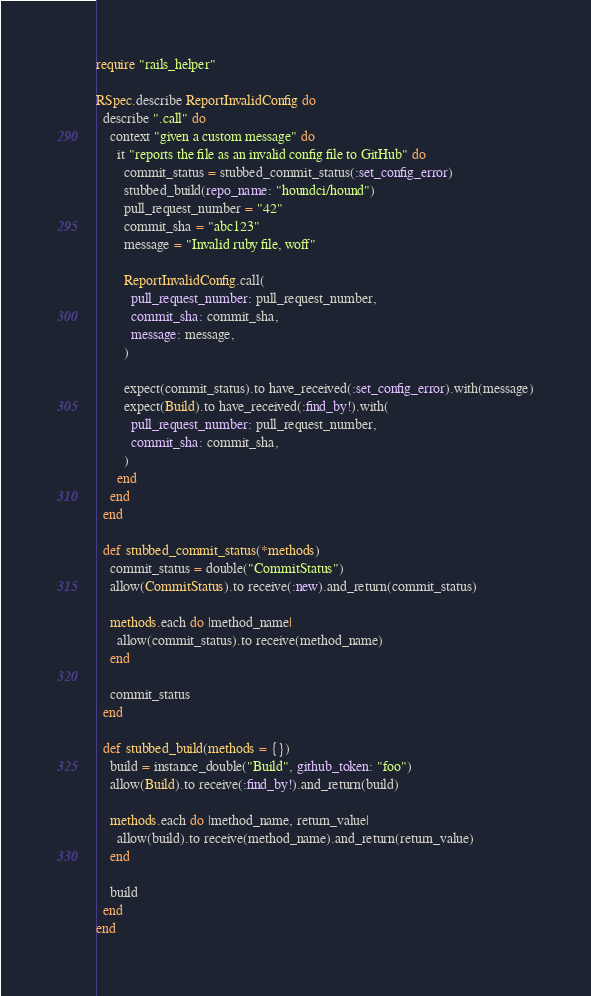Convert code to text. <code><loc_0><loc_0><loc_500><loc_500><_Ruby_>require "rails_helper"

RSpec.describe ReportInvalidConfig do
  describe ".call" do
    context "given a custom message" do
      it "reports the file as an invalid config file to GitHub" do
        commit_status = stubbed_commit_status(:set_config_error)
        stubbed_build(repo_name: "houndci/hound")
        pull_request_number = "42"
        commit_sha = "abc123"
        message = "Invalid ruby file, woff"

        ReportInvalidConfig.call(
          pull_request_number: pull_request_number,
          commit_sha: commit_sha,
          message: message,
        )

        expect(commit_status).to have_received(:set_config_error).with(message)
        expect(Build).to have_received(:find_by!).with(
          pull_request_number: pull_request_number,
          commit_sha: commit_sha,
        )
      end
    end
  end

  def stubbed_commit_status(*methods)
    commit_status = double("CommitStatus")
    allow(CommitStatus).to receive(:new).and_return(commit_status)

    methods.each do |method_name|
      allow(commit_status).to receive(method_name)
    end

    commit_status
  end

  def stubbed_build(methods = {})
    build = instance_double("Build", github_token: "foo")
    allow(Build).to receive(:find_by!).and_return(build)

    methods.each do |method_name, return_value|
      allow(build).to receive(method_name).and_return(return_value)
    end

    build
  end
end
</code> 